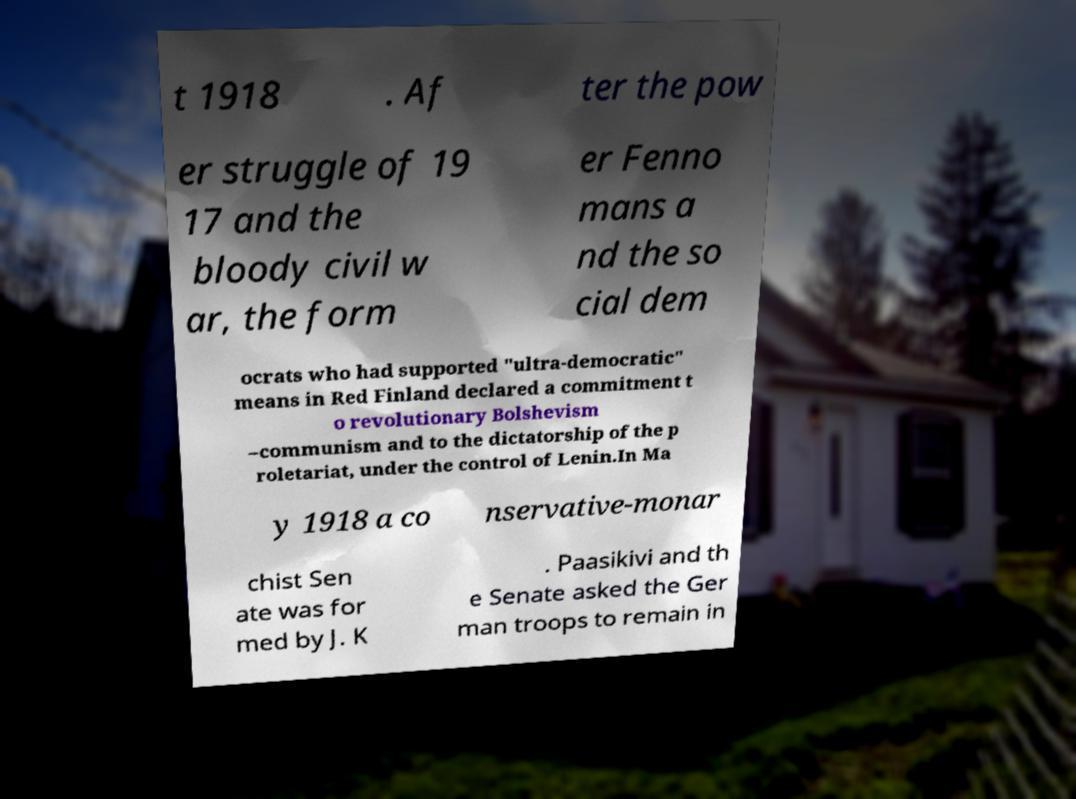I need the written content from this picture converted into text. Can you do that? t 1918 . Af ter the pow er struggle of 19 17 and the bloody civil w ar, the form er Fenno mans a nd the so cial dem ocrats who had supported "ultra-democratic" means in Red Finland declared a commitment t o revolutionary Bolshevism –communism and to the dictatorship of the p roletariat, under the control of Lenin.In Ma y 1918 a co nservative-monar chist Sen ate was for med by J. K . Paasikivi and th e Senate asked the Ger man troops to remain in 